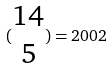<formula> <loc_0><loc_0><loc_500><loc_500>( \begin{matrix} 1 4 \\ 5 \end{matrix} ) = 2 0 0 2</formula> 